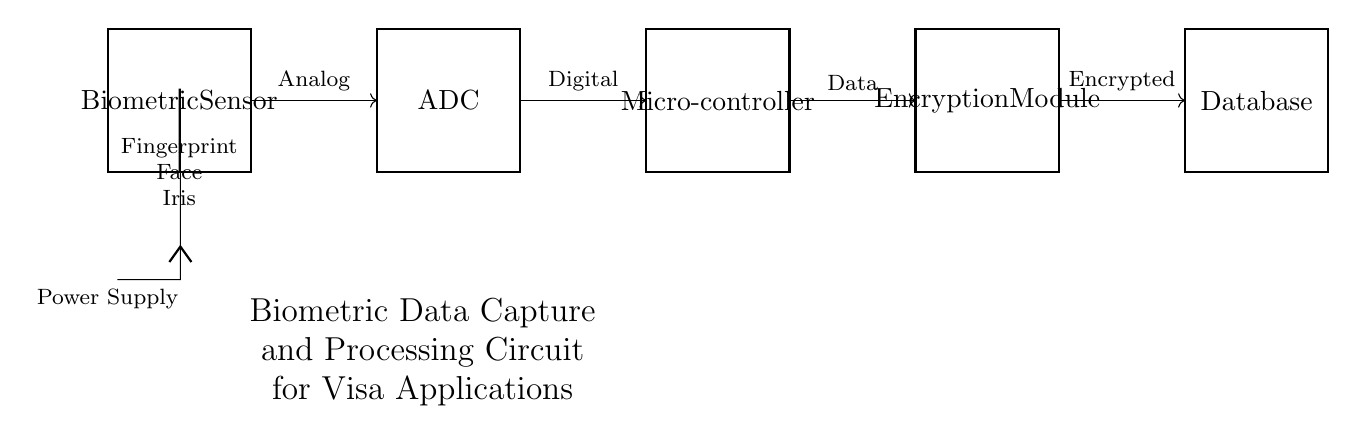What is the main input type for the biometric sensor? The main input type for the biometric sensor is fingerprint, face, and iris data, as indicated in the labels connected to the sensor component.
Answer: fingerprint, face, iris What is the function of the analog-to-digital converter? The analog-to-digital converter's function is to convert the analog signals received from the biometric sensor into digital data, which is necessary for processing by the microcontroller.
Answer: convert analog to digital Which component follows the ADC in the circuit? The component that follows the ADC in the circuit is the microcontroller, which processes the digital data received from the ADC.
Answer: microcontroller What type of data does the encryption module output? The encryption module outputs encrypted data, which is processed data protected for security purposes, indicated by the label on the output connection.
Answer: Encrypted Why is a power supply necessary in this circuit? A power supply is necessary in this circuit to provide the required voltage to the biometric sensor and other components, ensuring that the circuit operates properly.
Answer: to provide voltage How are the connections made between the biometric sensor and the encryption module? The connections between the components are made through directed arrows indicating the flow of data: the sensor sends analog signals to the ADC, which then sends digital data to the microcontroller, followed by the encryption module.
Answer: directed arrows What type of circuit is this specifically categorized as? This circuit is specifically categorized as a digital circuit because it involves the conversion of analog signals to digital data for processing and encryption, which are characteristic features of digital systems.
Answer: digital circuit 